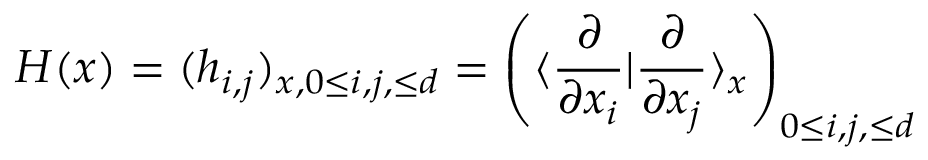Convert formula to latex. <formula><loc_0><loc_0><loc_500><loc_500>H ( x ) = ( h _ { i , j } ) _ { x , 0 \leq i , j , \leq d } = \left ( \langle \frac { \partial } { \partial x _ { i } } | \frac { \partial } { \partial x _ { j } } \rangle _ { x } \right ) _ { 0 \leq i , j , \leq d }</formula> 